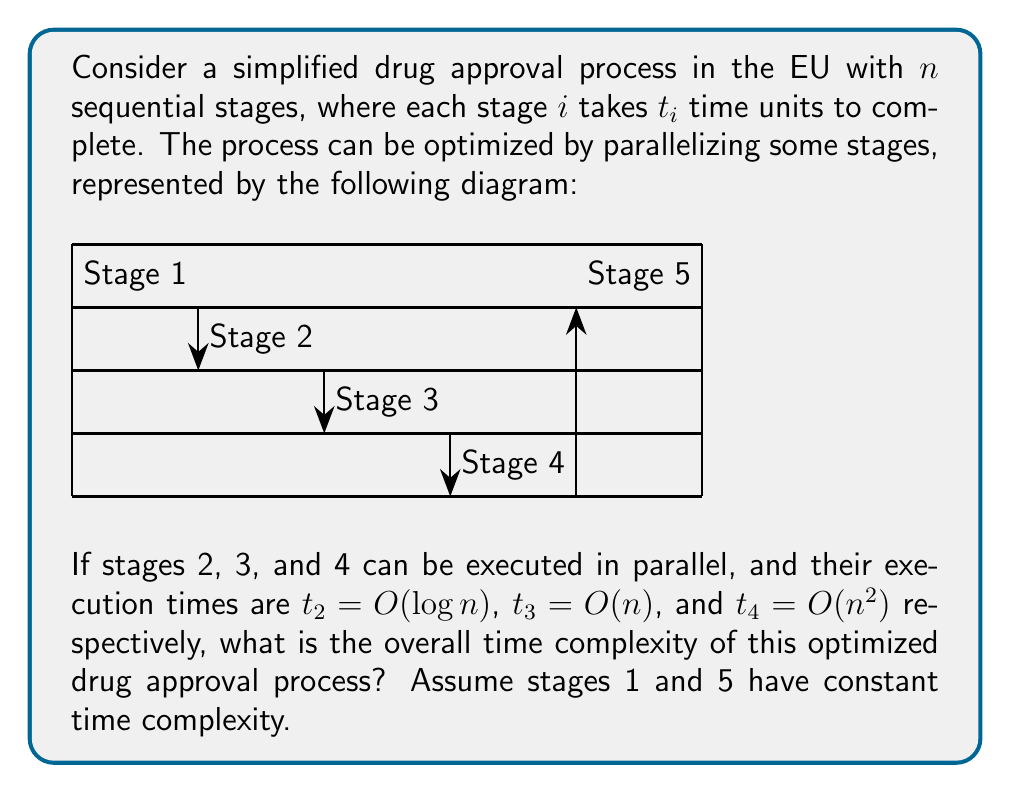Can you answer this question? Let's analyze the time complexity step by step:

1) First, we need to identify the critical path in the parallel execution:
   - Stages 2, 3, and 4 are executed in parallel
   - The time for this parallel section will be determined by the slowest of these three stages

2) Comparing the time complexities of stages 2, 3, and 4:
   - Stage 2: $O(\log n)$
   - Stage 3: $O(n)$
   - Stage 4: $O(n^2)$

3) Among these, $O(n^2)$ is the dominant term, so the parallel section will take $O(n^2)$ time.

4) Now, let's consider the entire process:
   - Stage 1: $O(1)$ (constant time)
   - Parallel section (Stages 2, 3, 4): $O(n^2)$
   - Stage 5: $O(1)$ (constant time)

5) The total time complexity is the sum of these parts:
   $$ O(1) + O(n^2) + O(1) = O(n^2) $$

6) The constant terms $O(1)$ are negligible compared to $O(n^2)$ for large $n$, so they don't affect the overall complexity.

Therefore, the overall time complexity of the optimized drug approval process is $O(n^2)$.
Answer: $O(n^2)$ 